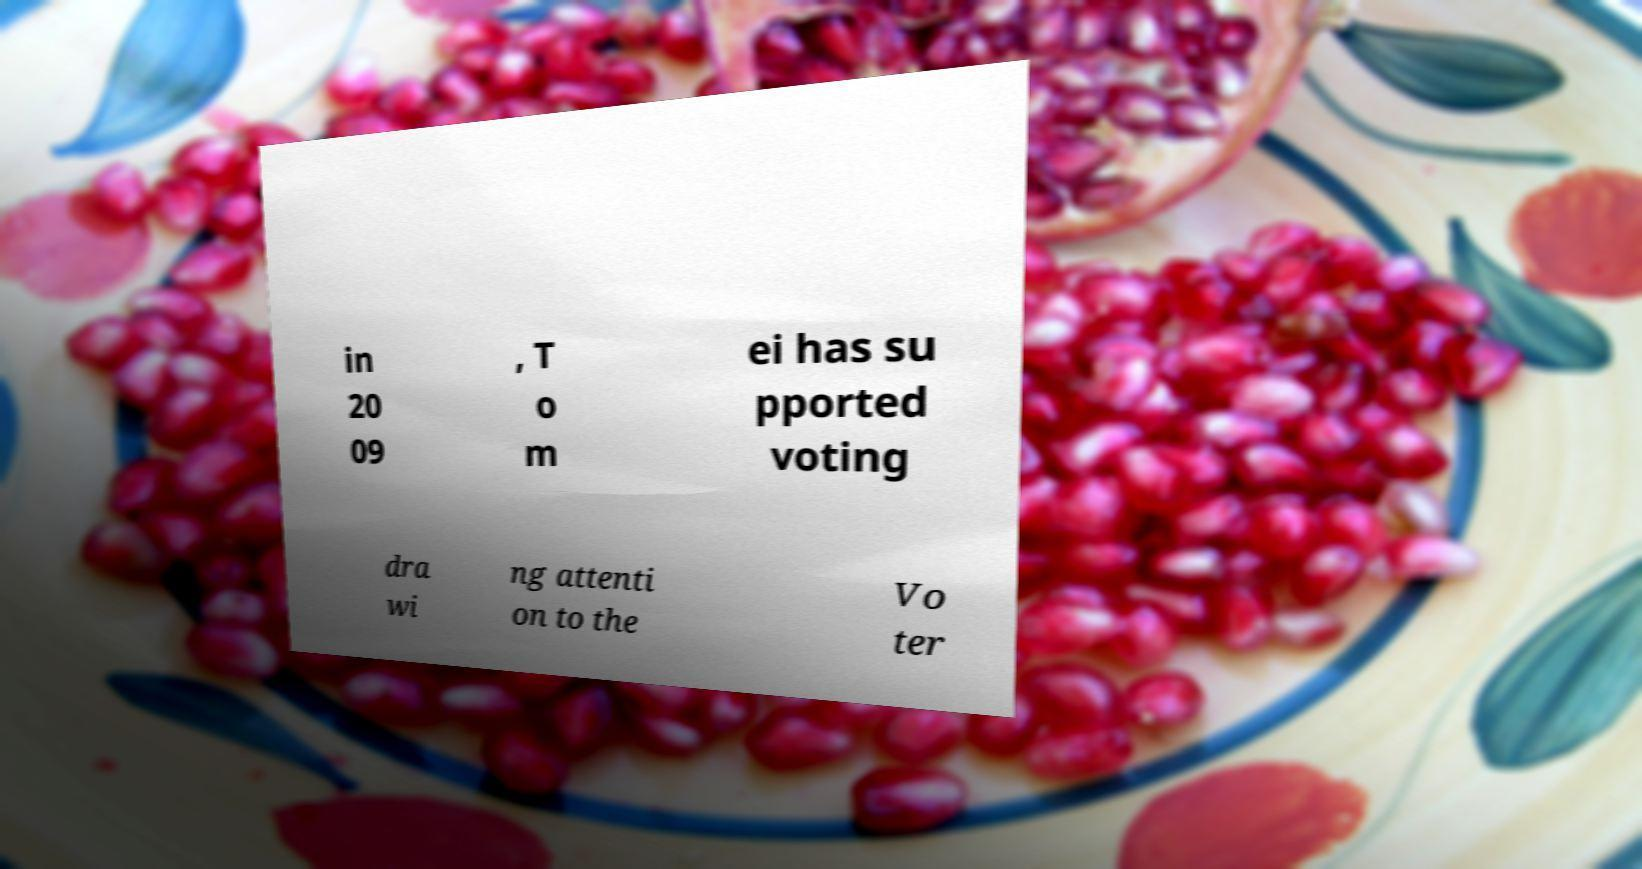Can you accurately transcribe the text from the provided image for me? in 20 09 , T o m ei has su pported voting dra wi ng attenti on to the Vo ter 